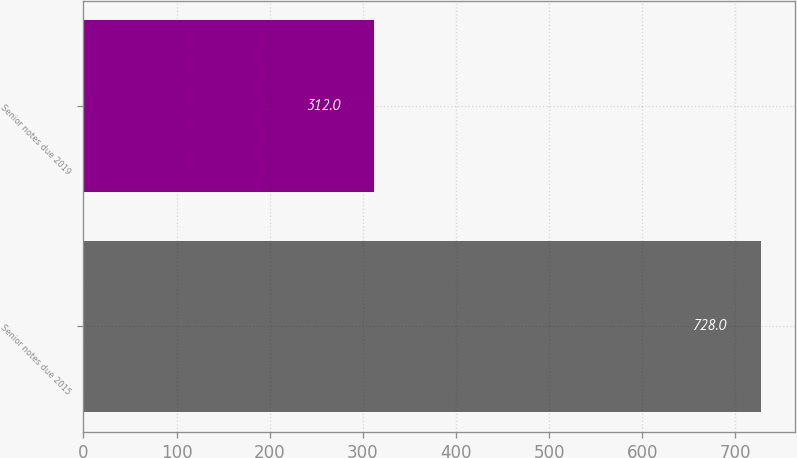Convert chart to OTSL. <chart><loc_0><loc_0><loc_500><loc_500><bar_chart><fcel>Senior notes due 2015<fcel>Senior notes due 2019<nl><fcel>728<fcel>312<nl></chart> 